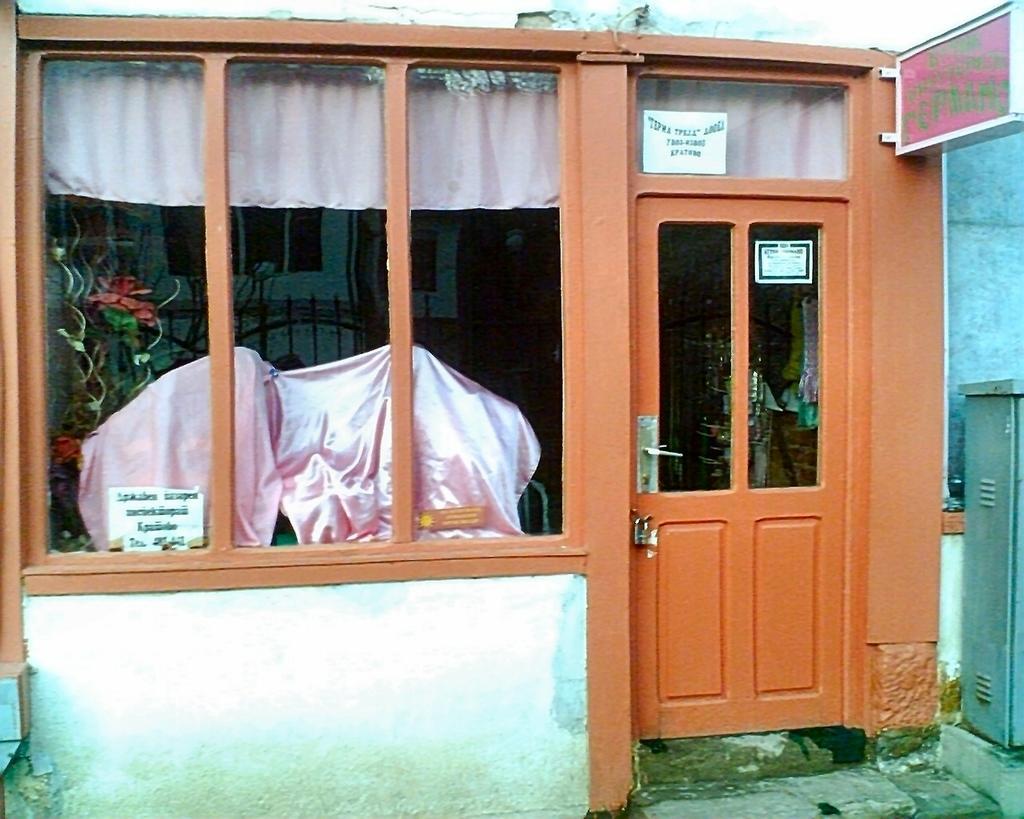In one or two sentences, can you explain what this image depicts? In the center of the image there is a house. There is a door. There are windows. 